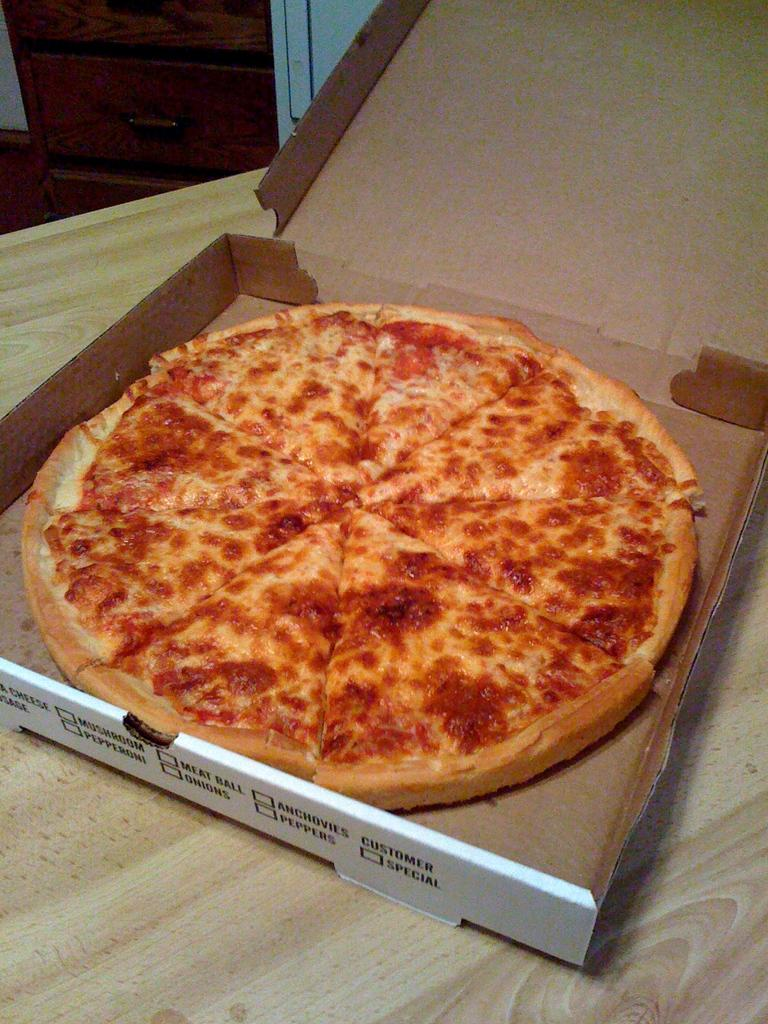What is on the table in the image? There is a pizza box on the table. How is the table referred to in the image? The table is described as a desk. How does the impulse affect the bridge in the image? There is no bridge present in the image, and therefore no impulse can be observed. 